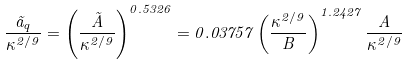<formula> <loc_0><loc_0><loc_500><loc_500>\frac { \tilde { a } _ { q } } { \kappa ^ { 2 / 9 } } = \left ( \frac { \tilde { A } } { \kappa ^ { 2 / 9 } } \right ) ^ { 0 . 5 3 2 6 } = 0 . 0 3 7 5 7 \left ( \frac { \kappa ^ { 2 / 9 } } { B } \right ) ^ { 1 . 2 4 2 7 } \frac { A } { \kappa ^ { 2 / 9 } }</formula> 